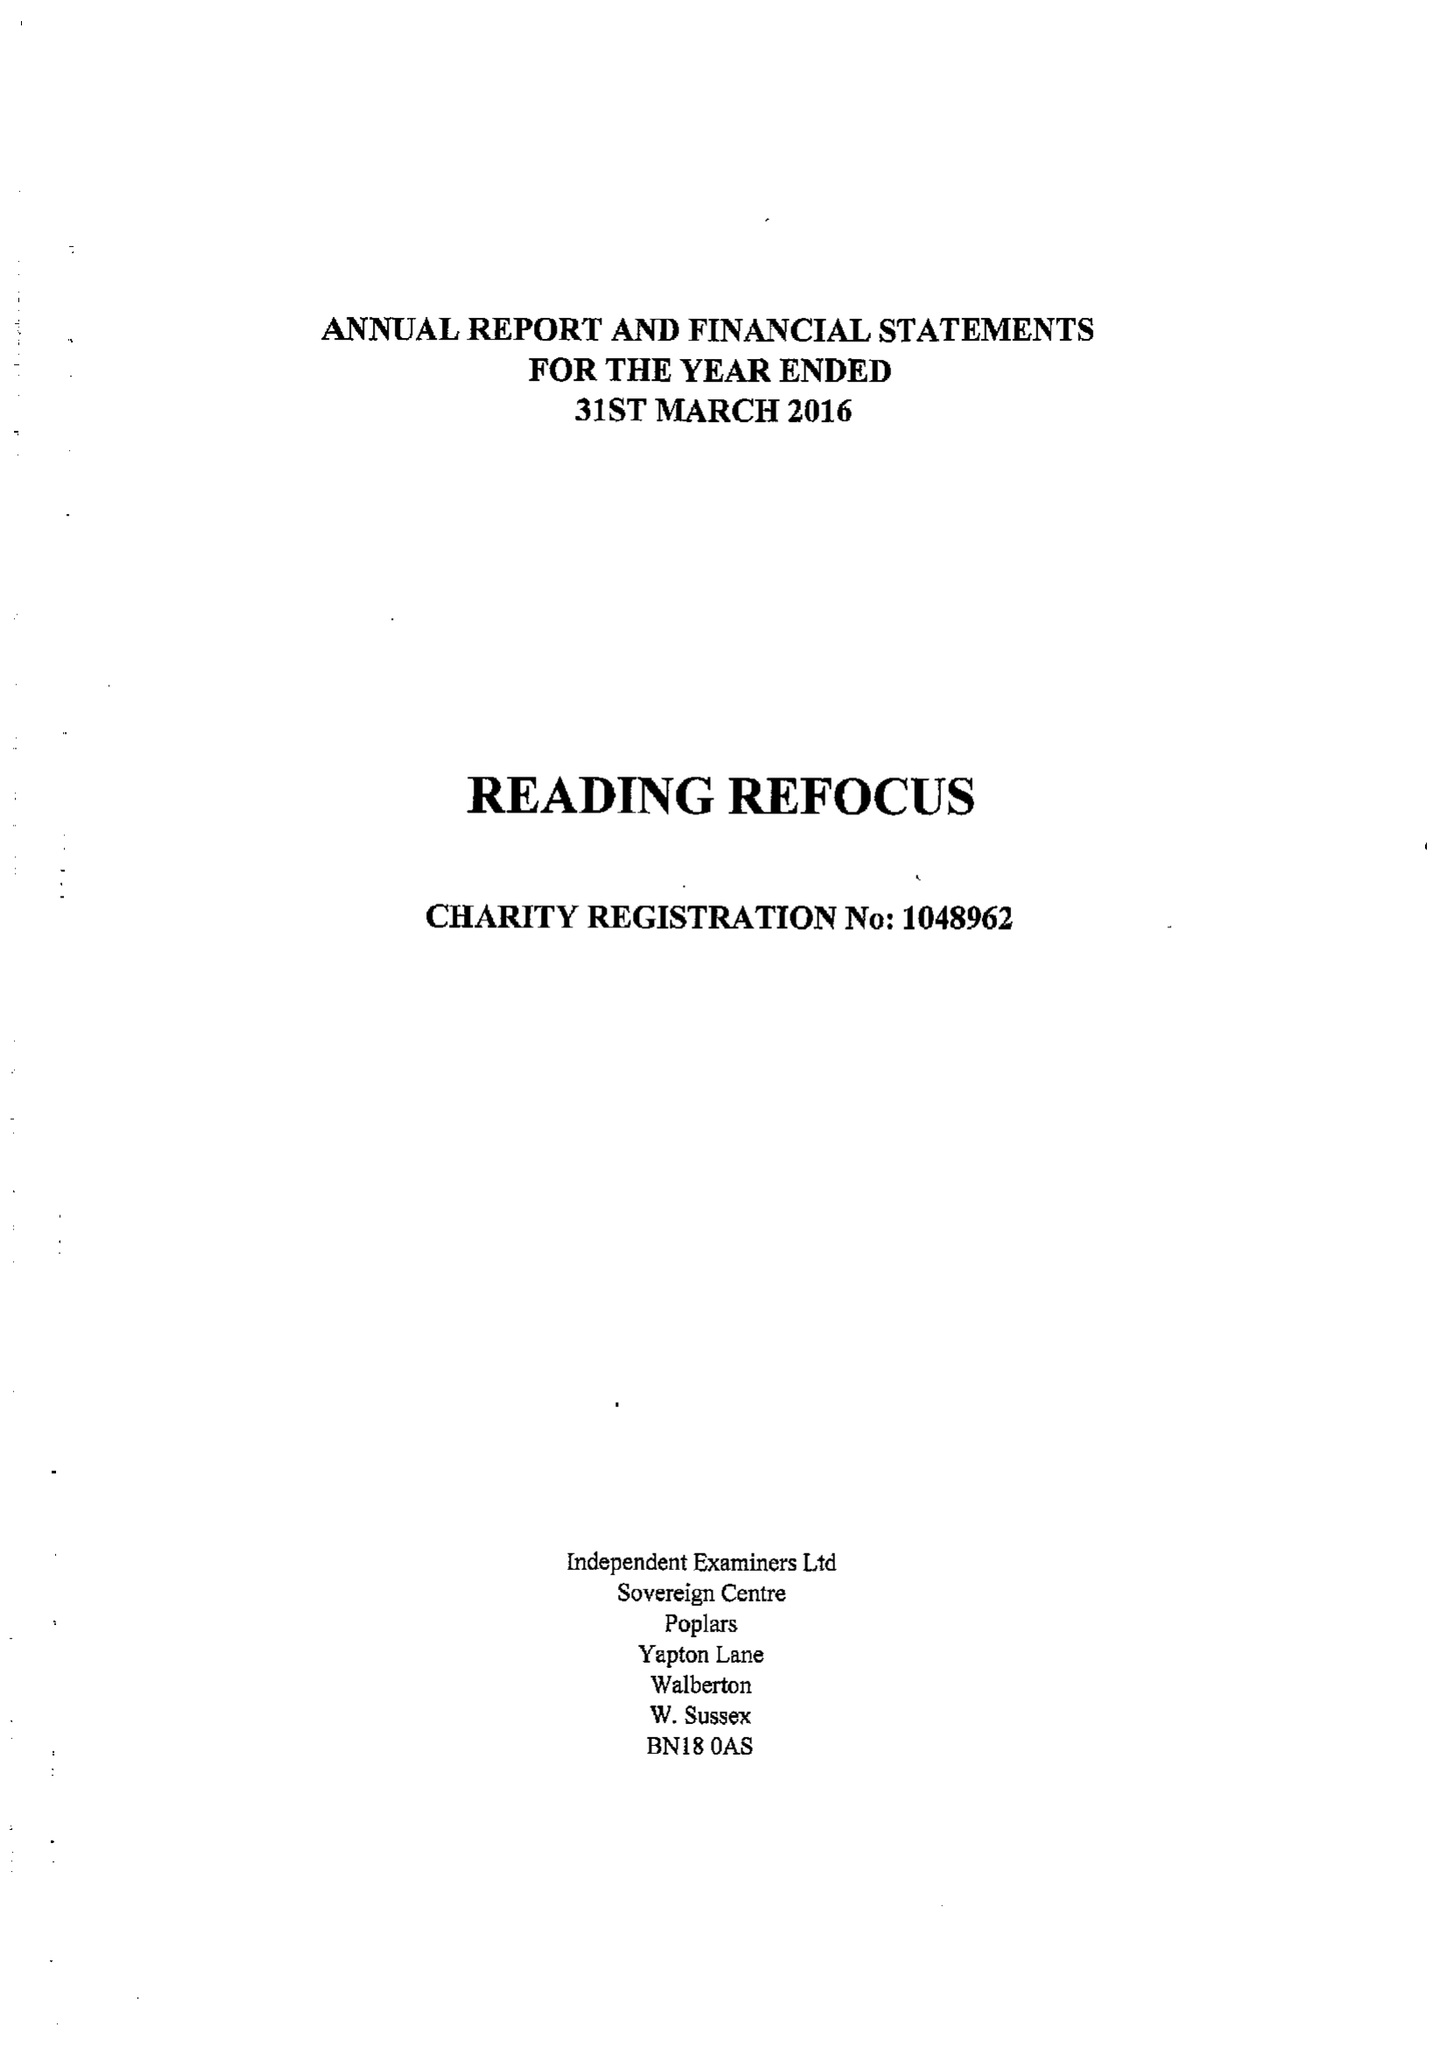What is the value for the charity_number?
Answer the question using a single word or phrase. 1048962 